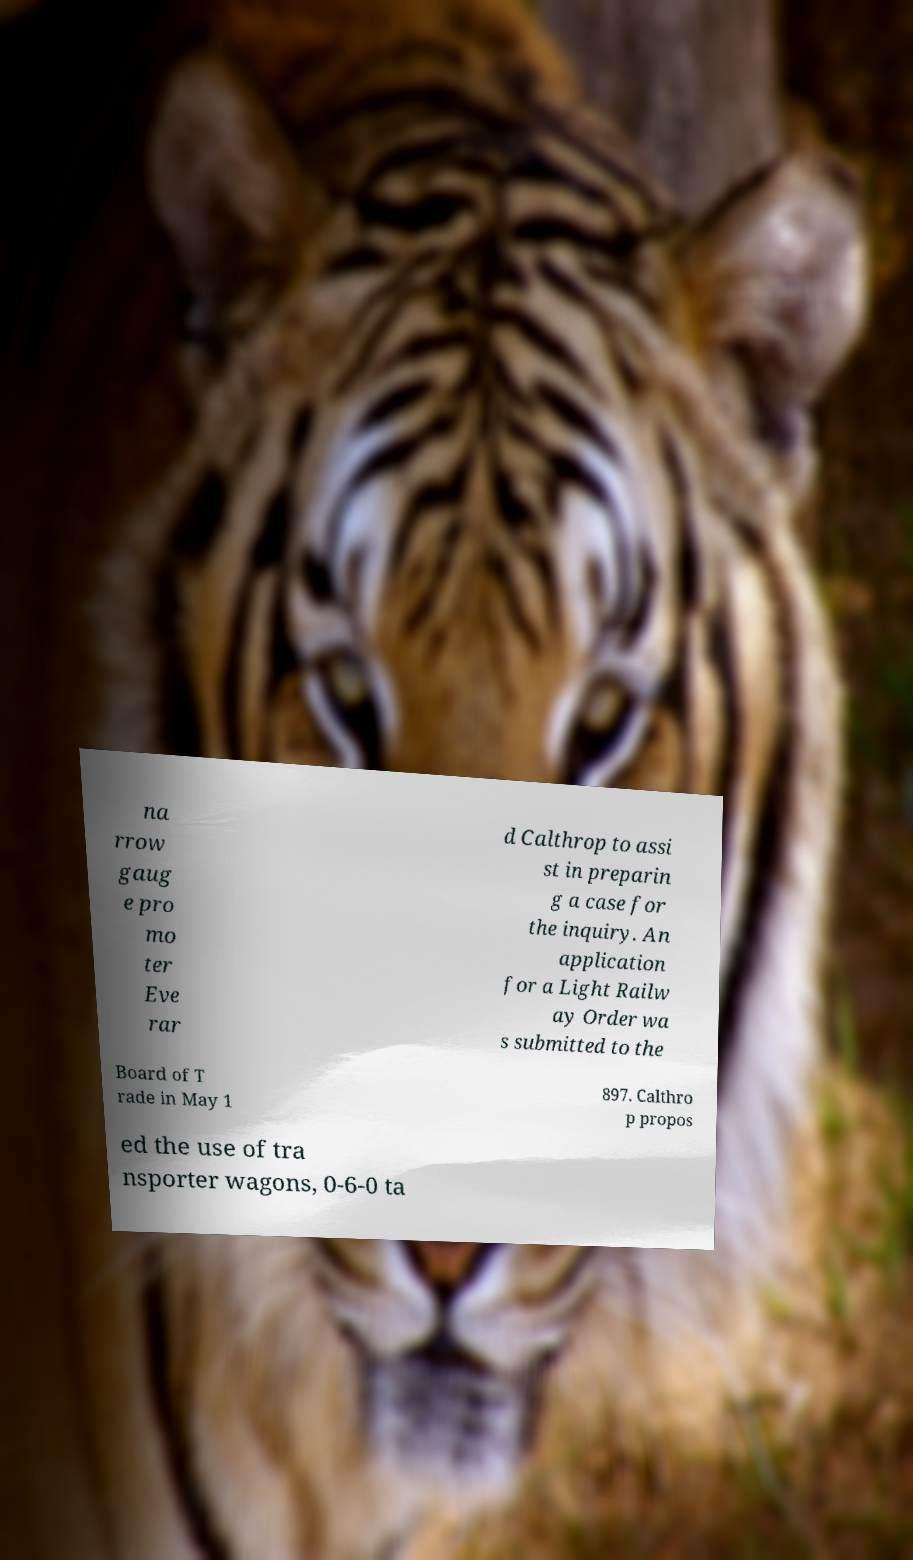Could you extract and type out the text from this image? na rrow gaug e pro mo ter Eve rar d Calthrop to assi st in preparin g a case for the inquiry. An application for a Light Railw ay Order wa s submitted to the Board of T rade in May 1 897. Calthro p propos ed the use of tra nsporter wagons, 0-6-0 ta 